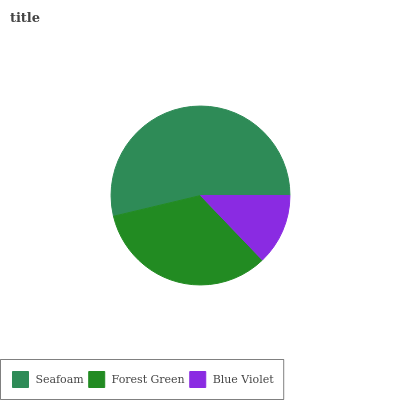Is Blue Violet the minimum?
Answer yes or no. Yes. Is Seafoam the maximum?
Answer yes or no. Yes. Is Forest Green the minimum?
Answer yes or no. No. Is Forest Green the maximum?
Answer yes or no. No. Is Seafoam greater than Forest Green?
Answer yes or no. Yes. Is Forest Green less than Seafoam?
Answer yes or no. Yes. Is Forest Green greater than Seafoam?
Answer yes or no. No. Is Seafoam less than Forest Green?
Answer yes or no. No. Is Forest Green the high median?
Answer yes or no. Yes. Is Forest Green the low median?
Answer yes or no. Yes. Is Blue Violet the high median?
Answer yes or no. No. Is Blue Violet the low median?
Answer yes or no. No. 